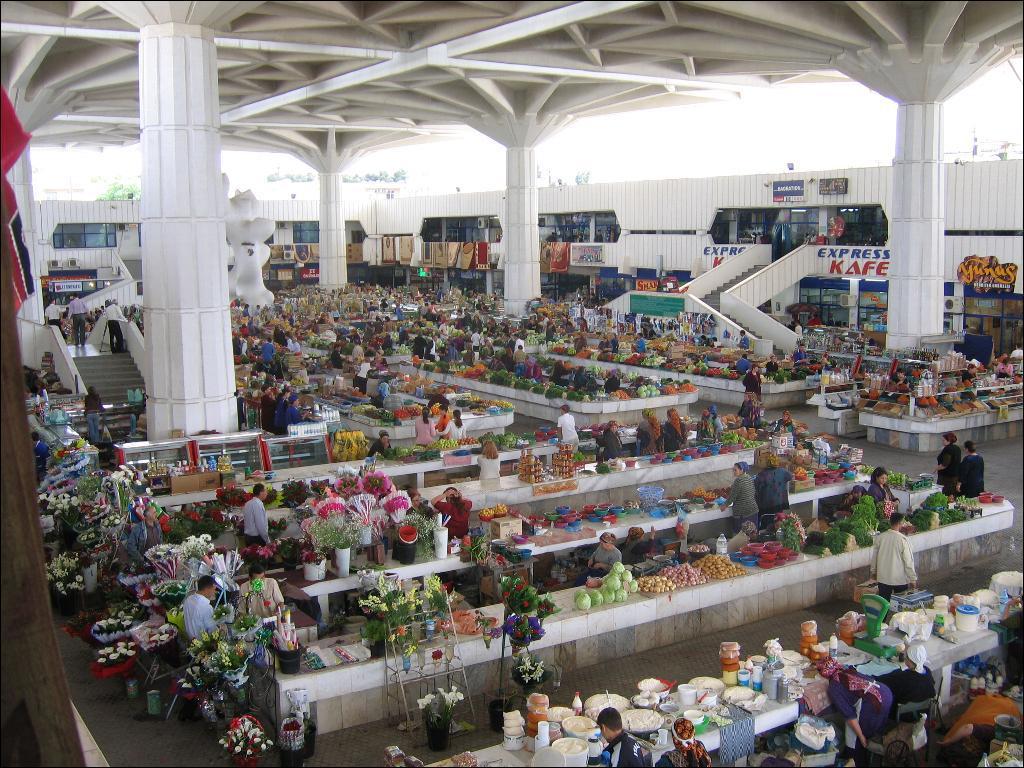What company s here?
Keep it short and to the point. Express kafe. 